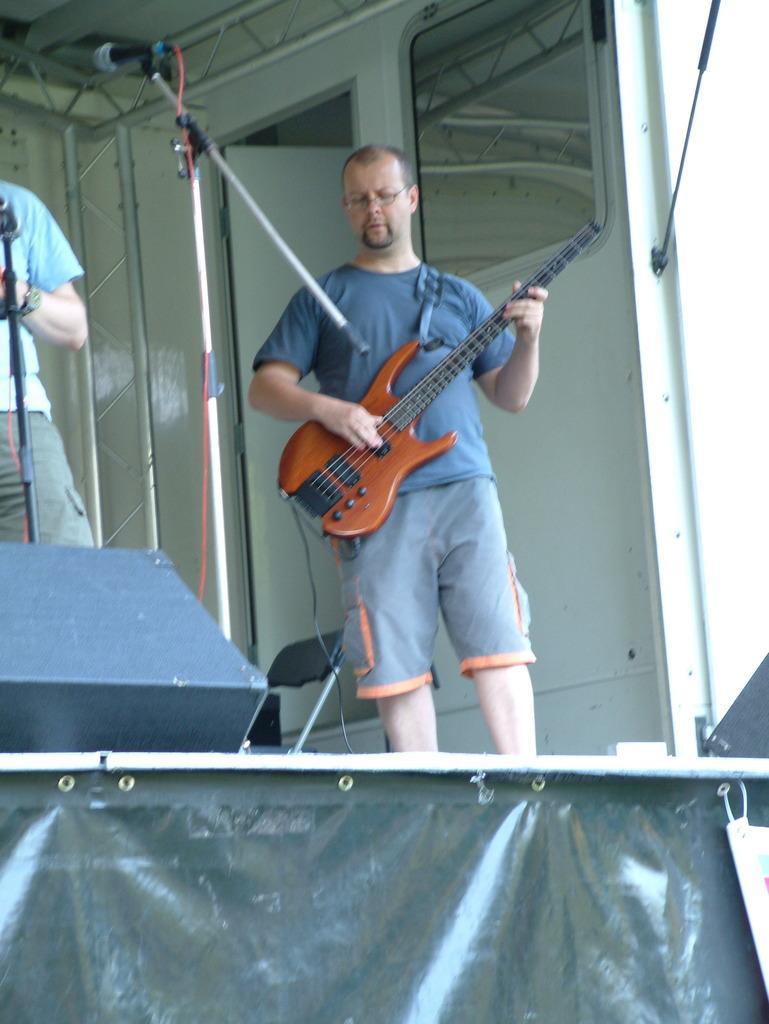Please provide a concise description of this image. Here is a man standing and playing guitar. this is the mike with the mike stand. At left corner I can see another person standing. This is an empty chair. This looks like a black sheet. At background i can see a door which is white in color. 